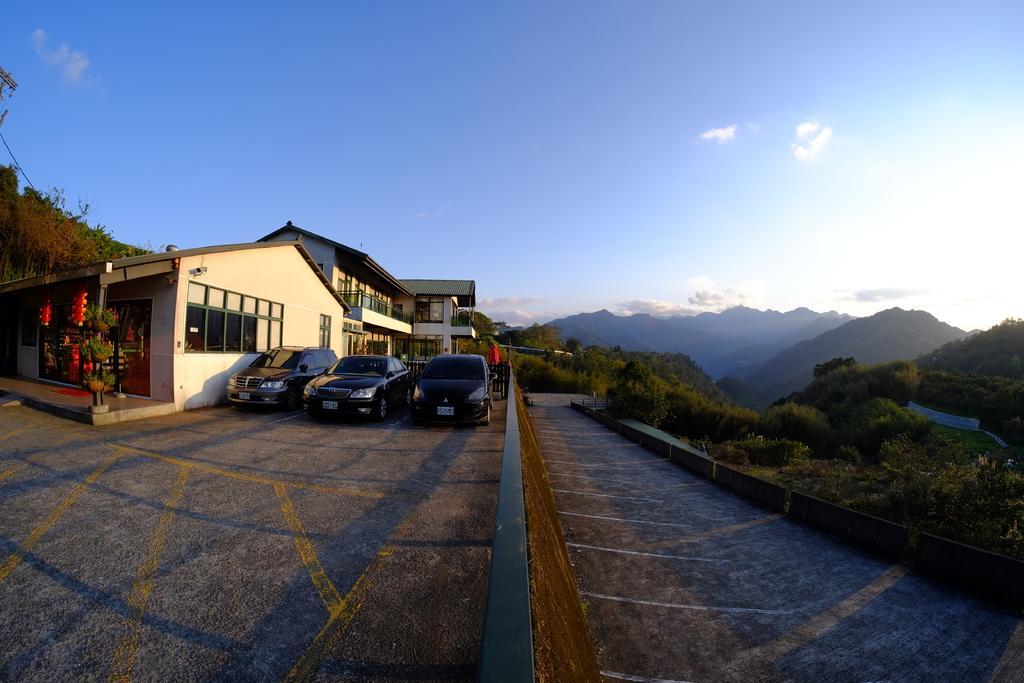Please provide a concise description of this image. At the bottom we can see vehicles on the road at the house and we can see house plants in the pots to a pole. In the background there are trees, houses, roof,windows, mountains and clouds in the sky. On the right side there is a road, trees, and plants on the ground. 